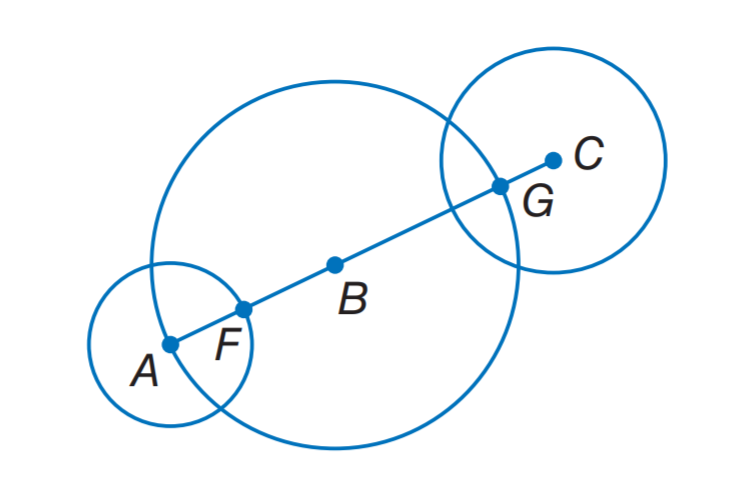Question: The diameters of \odot A, \odot B, and \odot C are 8 inches, 18 inches, and 11 inches, respectively. Find F B.
Choices:
A. 4
B. 5
C. 5.5
D. 11
Answer with the letter. Answer: B Question: The diameters of \odot A, \odot B, and \odot C are 8 inches, 18 inches, and 11 inches, respectively. Find F G.
Choices:
A. 7
B. 8
C. 14
D. 16
Answer with the letter. Answer: C 